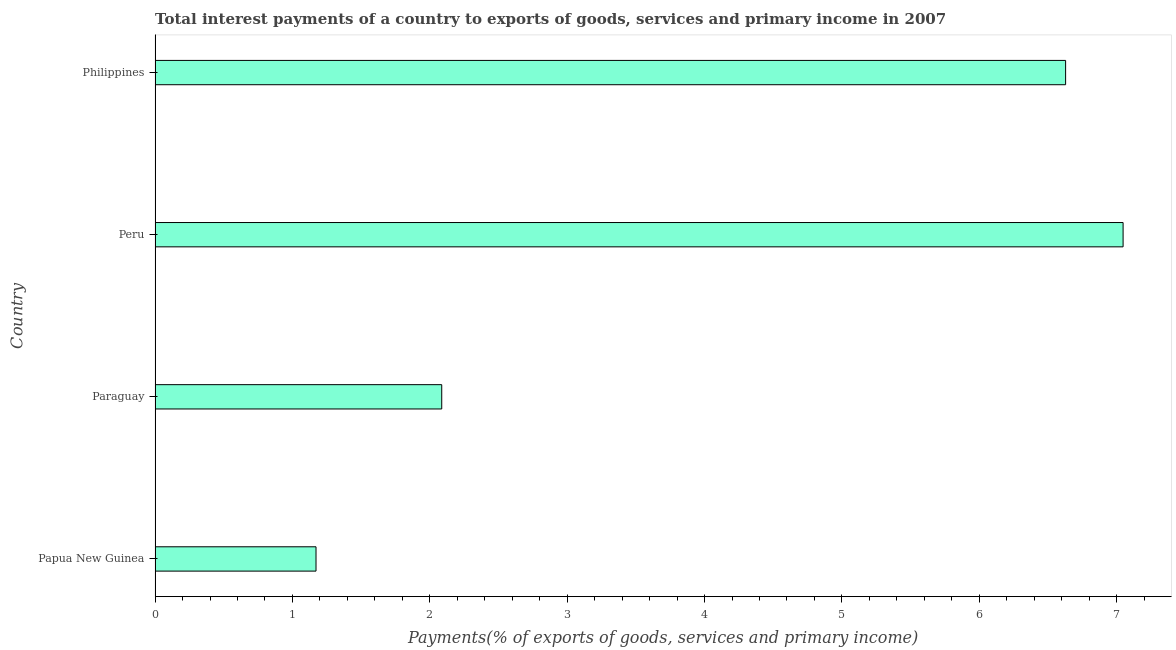Does the graph contain any zero values?
Provide a succinct answer. No. What is the title of the graph?
Provide a short and direct response. Total interest payments of a country to exports of goods, services and primary income in 2007. What is the label or title of the X-axis?
Your answer should be very brief. Payments(% of exports of goods, services and primary income). What is the total interest payments on external debt in Paraguay?
Offer a terse response. 2.09. Across all countries, what is the maximum total interest payments on external debt?
Offer a terse response. 7.05. Across all countries, what is the minimum total interest payments on external debt?
Ensure brevity in your answer.  1.17. In which country was the total interest payments on external debt maximum?
Ensure brevity in your answer.  Peru. In which country was the total interest payments on external debt minimum?
Your answer should be very brief. Papua New Guinea. What is the sum of the total interest payments on external debt?
Give a very brief answer. 16.93. What is the difference between the total interest payments on external debt in Paraguay and Peru?
Offer a very short reply. -4.96. What is the average total interest payments on external debt per country?
Offer a very short reply. 4.23. What is the median total interest payments on external debt?
Offer a very short reply. 4.36. What is the ratio of the total interest payments on external debt in Peru to that in Philippines?
Your answer should be compact. 1.06. What is the difference between the highest and the second highest total interest payments on external debt?
Ensure brevity in your answer.  0.42. What is the difference between the highest and the lowest total interest payments on external debt?
Offer a terse response. 5.88. How many countries are there in the graph?
Your response must be concise. 4. What is the difference between two consecutive major ticks on the X-axis?
Make the answer very short. 1. Are the values on the major ticks of X-axis written in scientific E-notation?
Your answer should be very brief. No. What is the Payments(% of exports of goods, services and primary income) of Papua New Guinea?
Your response must be concise. 1.17. What is the Payments(% of exports of goods, services and primary income) in Paraguay?
Make the answer very short. 2.09. What is the Payments(% of exports of goods, services and primary income) of Peru?
Provide a short and direct response. 7.05. What is the Payments(% of exports of goods, services and primary income) of Philippines?
Provide a succinct answer. 6.63. What is the difference between the Payments(% of exports of goods, services and primary income) in Papua New Guinea and Paraguay?
Provide a short and direct response. -0.92. What is the difference between the Payments(% of exports of goods, services and primary income) in Papua New Guinea and Peru?
Offer a terse response. -5.88. What is the difference between the Payments(% of exports of goods, services and primary income) in Papua New Guinea and Philippines?
Provide a short and direct response. -5.46. What is the difference between the Payments(% of exports of goods, services and primary income) in Paraguay and Peru?
Provide a succinct answer. -4.96. What is the difference between the Payments(% of exports of goods, services and primary income) in Paraguay and Philippines?
Ensure brevity in your answer.  -4.54. What is the difference between the Payments(% of exports of goods, services and primary income) in Peru and Philippines?
Keep it short and to the point. 0.42. What is the ratio of the Payments(% of exports of goods, services and primary income) in Papua New Guinea to that in Paraguay?
Your response must be concise. 0.56. What is the ratio of the Payments(% of exports of goods, services and primary income) in Papua New Guinea to that in Peru?
Your answer should be compact. 0.17. What is the ratio of the Payments(% of exports of goods, services and primary income) in Papua New Guinea to that in Philippines?
Your answer should be very brief. 0.18. What is the ratio of the Payments(% of exports of goods, services and primary income) in Paraguay to that in Peru?
Make the answer very short. 0.3. What is the ratio of the Payments(% of exports of goods, services and primary income) in Paraguay to that in Philippines?
Make the answer very short. 0.32. What is the ratio of the Payments(% of exports of goods, services and primary income) in Peru to that in Philippines?
Ensure brevity in your answer.  1.06. 